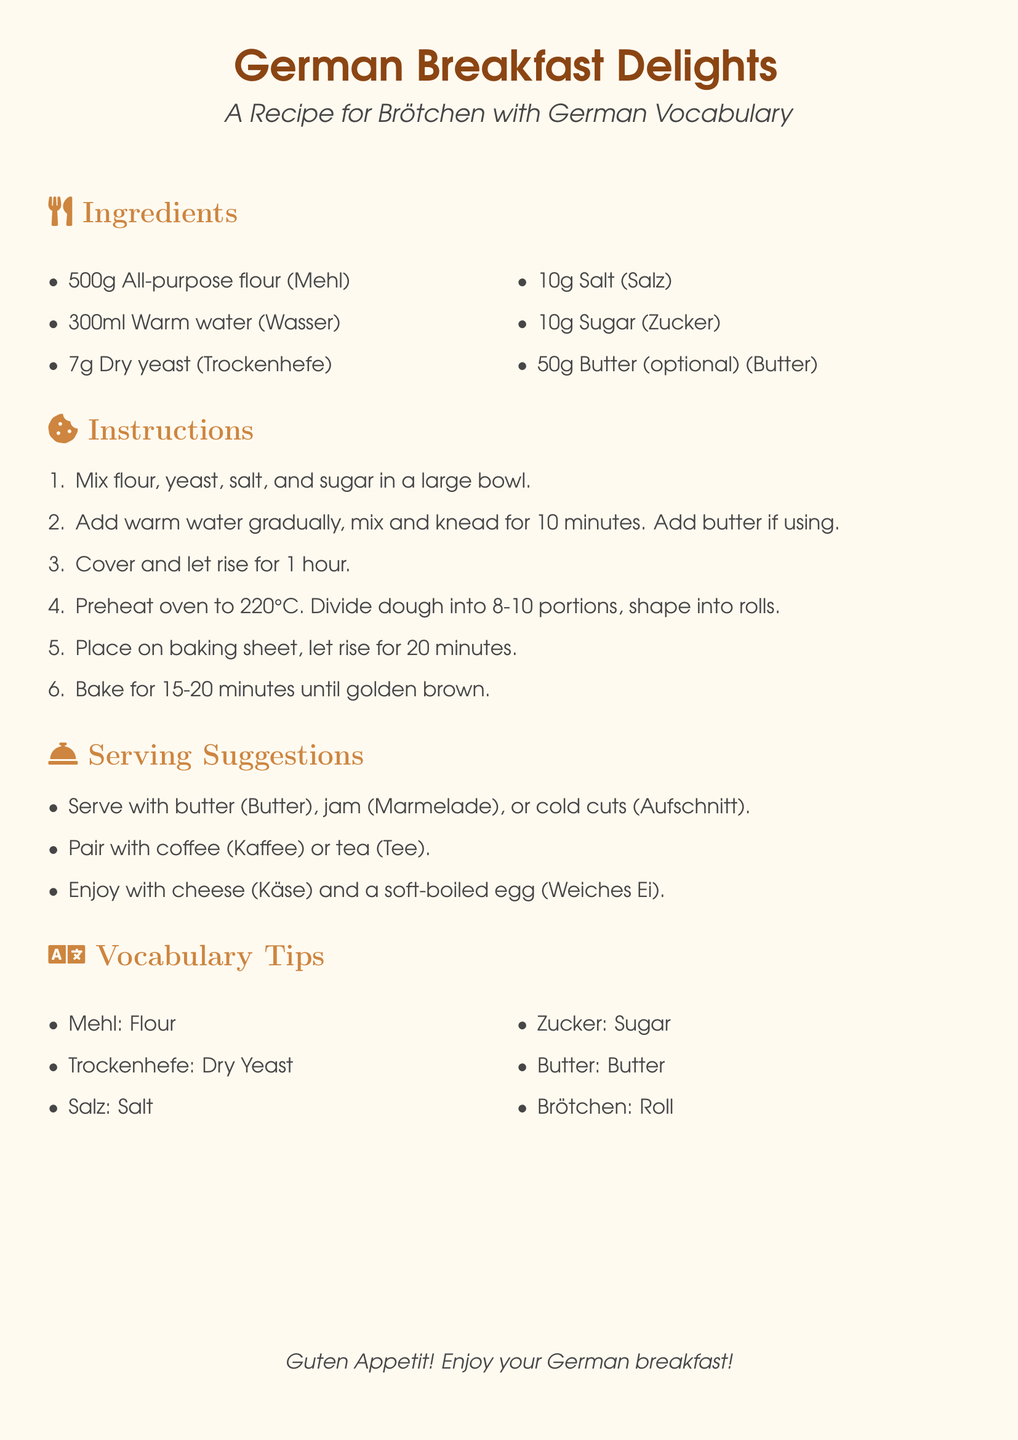What is the main ingredient for Brötchen? The main ingredient is all-purpose flour, listed first in the ingredients section.
Answer: All-purpose flour How many grams of sugar are needed? The recipe specifies 10 grams of sugar in the ingredients.
Answer: 10g What temperature should the oven be preheated to? The instructions state to preheat the oven to 220 degrees Celsius.
Answer: 220°C What is the resting time for the dough after mixing? The dough needs to rise for 1 hour after mixing.
Answer: 1 hour What is the German word for butter? The vocabulary section provides the German translation for butter.
Answer: Butter How many portions should the dough be divided into? The instruction indicates that the dough should be divided into 8-10 portions.
Answer: 8-10 What is a suggested beverage to enjoy with Brötchen? The serving suggestions mention coffee as a pairing option.
Answer: Coffee What does "Käse" mean in English? The vocabulary section defines Käse as cheese in English.
Answer: Cheese What is one of the serving suggestions listed in the document? The document includes serving Brötchen with jam among other options.
Answer: Jam 